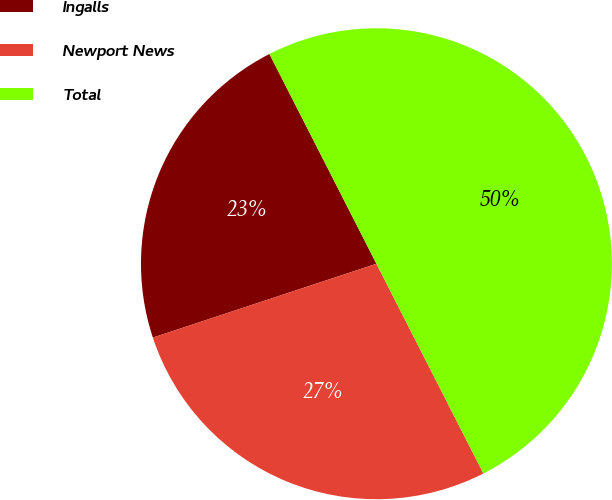Convert chart. <chart><loc_0><loc_0><loc_500><loc_500><pie_chart><fcel>Ingalls<fcel>Newport News<fcel>Total<nl><fcel>22.57%<fcel>27.43%<fcel>50.0%<nl></chart> 